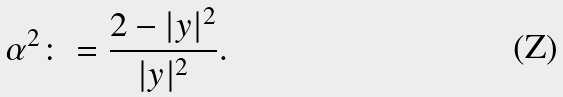<formula> <loc_0><loc_0><loc_500><loc_500>\alpha ^ { 2 } \colon = \frac { 2 - | y | ^ { 2 } } { | y | ^ { 2 } } .</formula> 